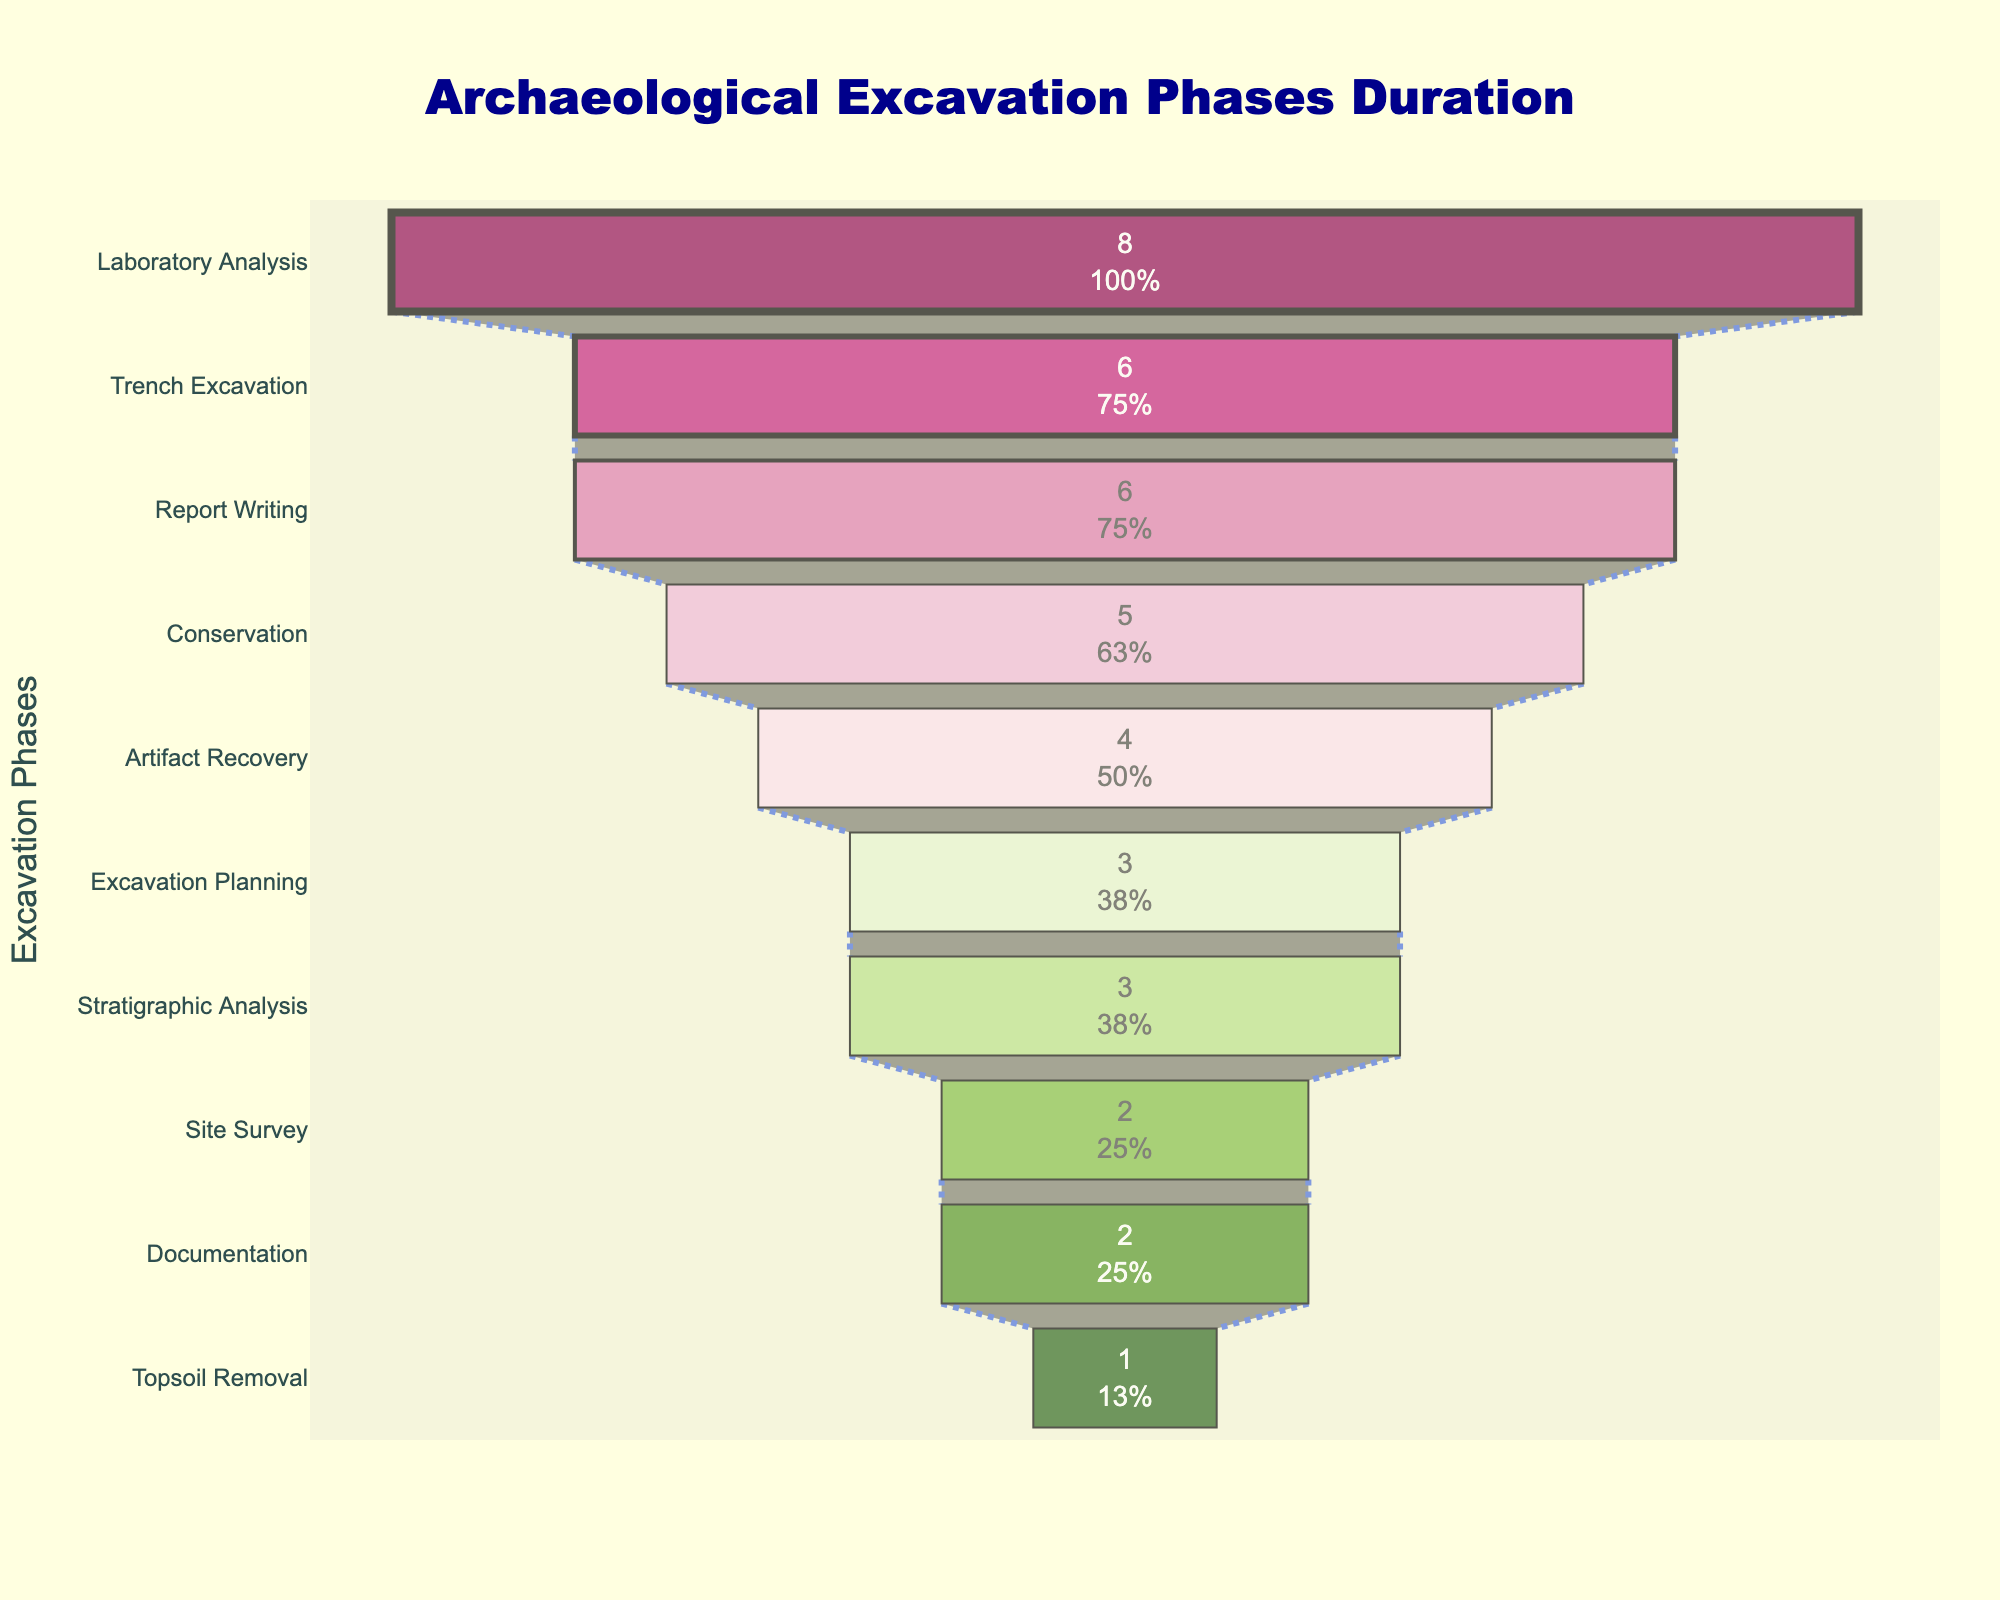What is the title of the funnel chart? The title is displayed at the top of the figure and provides a summary of what the chart represents. The title helps viewers quickly understand the topic of the chart.
Answer: Archaeological Excavation Phases Duration How many phases are depicted in the funnel chart? Count the number of phases listed on the y-axis of the funnel chart to determine the total number of unique activities in the archaeological excavation.
Answer: 10 Which phase takes the longest duration, and how many weeks is it? Identify the phase at the widest part of the funnel, indicating the longest duration. The duration in weeks is displayed inside the bar.
Answer: Laboratory Analysis, 8 weeks What is the total duration of all phases combined? Sum the duration values of all the phases. These durations are directly displayed in the chart. Add them up: 2 + 3 + 1 + 6 + 4 + 3 + 2 + 8 + 5 + 6.
Answer: 40 weeks Which phase has a duration greater than the Documentation phase but less than Laboratory Analysis? Compare the durations of all phases listed to find the one between the 2-week Documentation phase and the 8-week Laboratory Analysis phase.
Answer: Conservation, 5 weeks What is the difference in duration between the phase with the minimum duration and the phase with the maximum duration? Determine the shortest and longest durations from the chart, then subtract the shortest duration from the longest. The shortest duration is 1 week, and the longest is 8 weeks.
Answer: 7 weeks Which phases have equal durations? Identify all phases with identical duration values. Check the duration for each phase in the chart.
Answer: Excavation Planning and Stratigraphic Analysis, 3 weeks each; Report Writing and Trench Excavation, 6 weeks each What percentage of the total duration does the Topsoil Removal phase represent? The duration of the Topsoil Removal phase is 1 week. Calculate the percentage by dividing this by the total duration (40 weeks) and multiplying by 100%.
Answer: 2.5% What are the colors used to represent the phases in the chart? Describe the colors in the funnel chart that correspond to each phase. Notice the gradient from dark purples to light greens and dark reds to light browns.
Answer: Shades of purple, pink, light green, dark green, and dark brown How many phases take more than 3 weeks? Identify all phases with durations greater than 3 weeks by evaluating the duration of each phase and count them.
Answer: 4 phases 